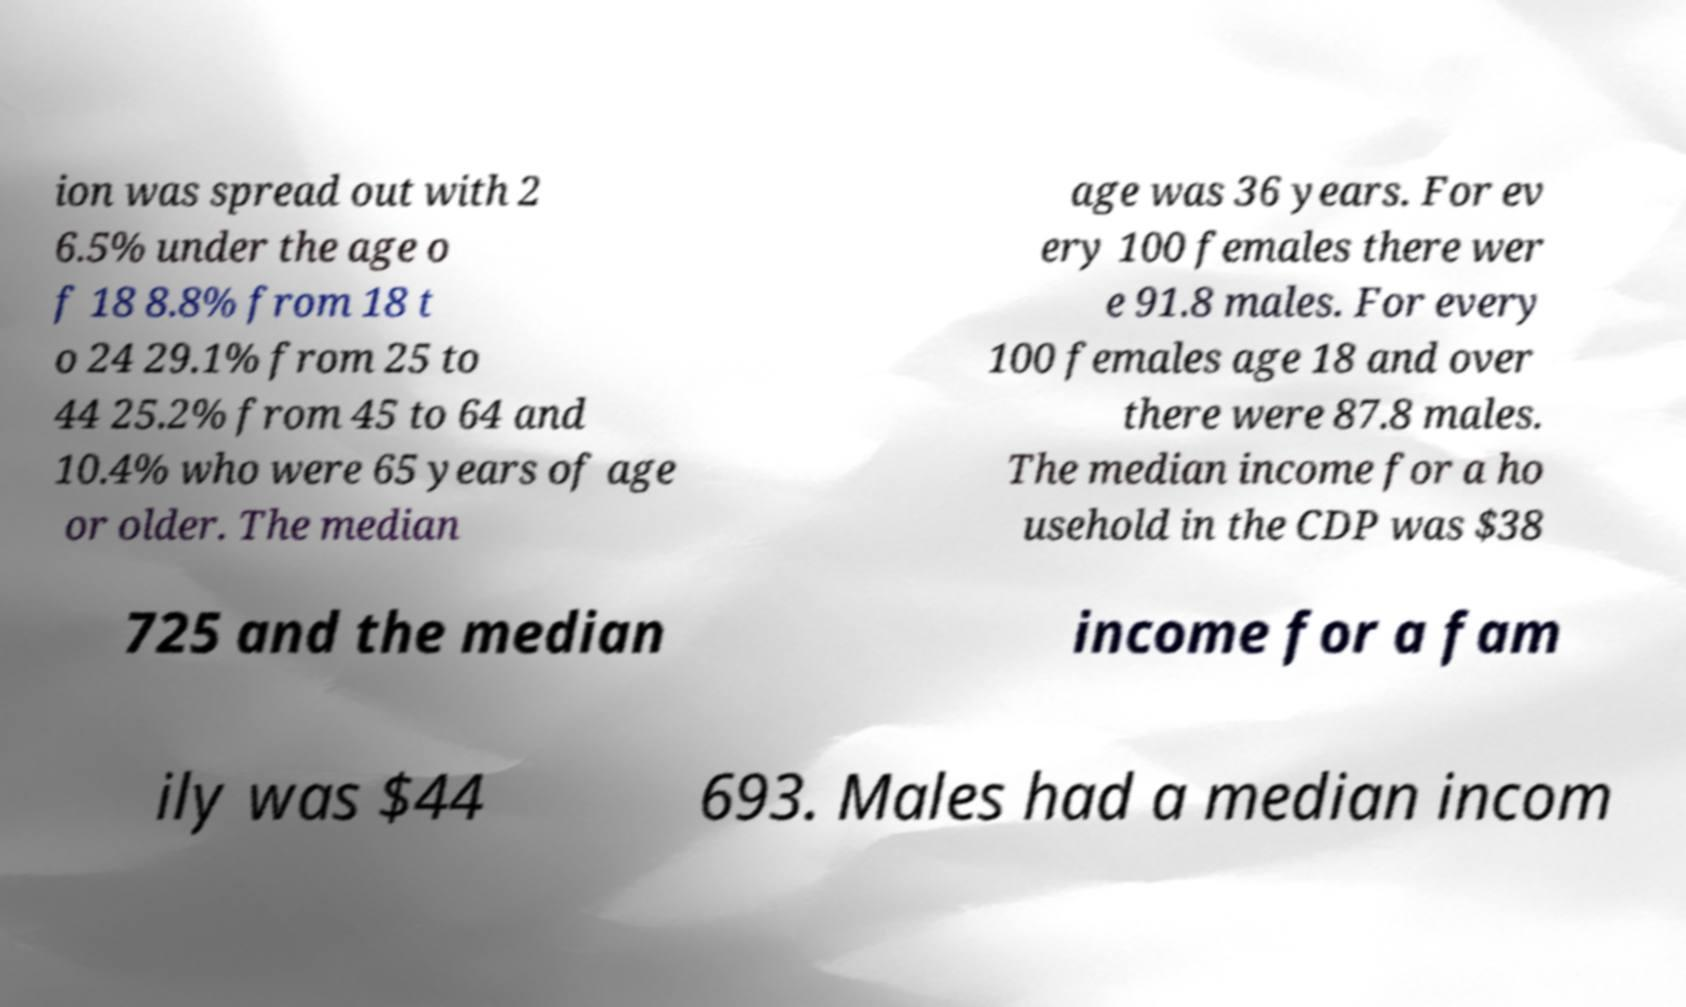Please identify and transcribe the text found in this image. ion was spread out with 2 6.5% under the age o f 18 8.8% from 18 t o 24 29.1% from 25 to 44 25.2% from 45 to 64 and 10.4% who were 65 years of age or older. The median age was 36 years. For ev ery 100 females there wer e 91.8 males. For every 100 females age 18 and over there were 87.8 males. The median income for a ho usehold in the CDP was $38 725 and the median income for a fam ily was $44 693. Males had a median incom 